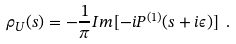Convert formula to latex. <formula><loc_0><loc_0><loc_500><loc_500>\rho _ { U } ( s ) = - \frac { 1 } { \pi } I m [ - i P ^ { ( 1 ) } ( s + i \epsilon ) ] \ .</formula> 